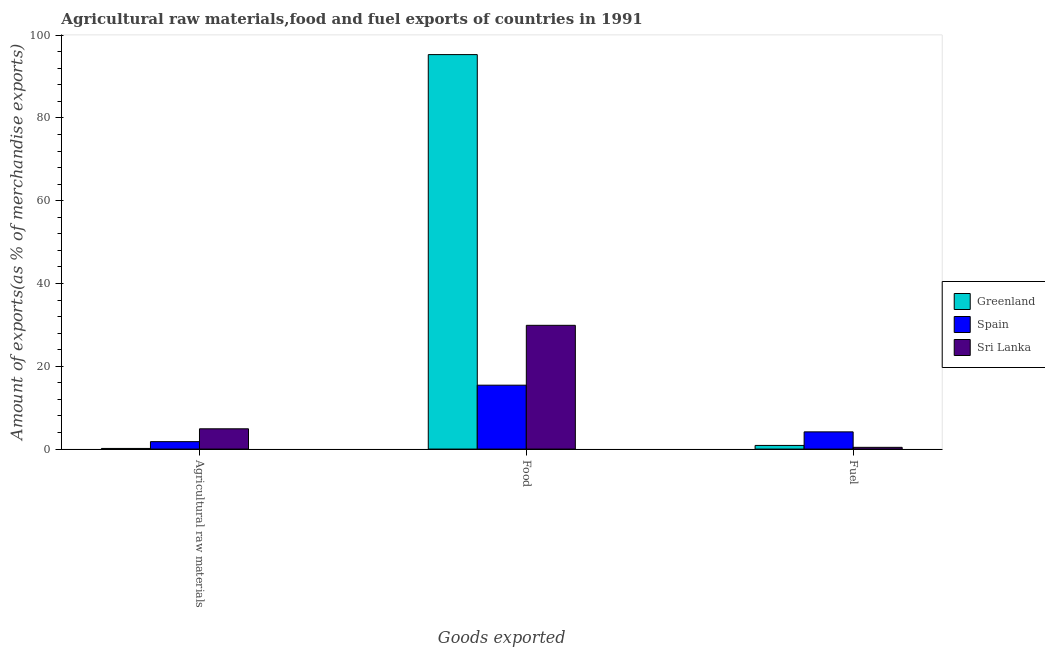How many groups of bars are there?
Your response must be concise. 3. Are the number of bars per tick equal to the number of legend labels?
Provide a succinct answer. Yes. Are the number of bars on each tick of the X-axis equal?
Offer a very short reply. Yes. What is the label of the 2nd group of bars from the left?
Ensure brevity in your answer.  Food. What is the percentage of food exports in Spain?
Your answer should be very brief. 15.44. Across all countries, what is the maximum percentage of raw materials exports?
Your response must be concise. 4.9. Across all countries, what is the minimum percentage of fuel exports?
Provide a short and direct response. 0.42. In which country was the percentage of fuel exports maximum?
Provide a short and direct response. Spain. In which country was the percentage of raw materials exports minimum?
Offer a terse response. Greenland. What is the total percentage of food exports in the graph?
Offer a very short reply. 140.66. What is the difference between the percentage of raw materials exports in Spain and that in Sri Lanka?
Offer a terse response. -3.1. What is the difference between the percentage of fuel exports in Greenland and the percentage of food exports in Sri Lanka?
Offer a very short reply. -29.02. What is the average percentage of food exports per country?
Keep it short and to the point. 46.89. What is the difference between the percentage of raw materials exports and percentage of fuel exports in Spain?
Your answer should be compact. -2.36. What is the ratio of the percentage of food exports in Spain to that in Greenland?
Ensure brevity in your answer.  0.16. Is the percentage of raw materials exports in Greenland less than that in Sri Lanka?
Keep it short and to the point. Yes. Is the difference between the percentage of raw materials exports in Spain and Sri Lanka greater than the difference between the percentage of food exports in Spain and Sri Lanka?
Provide a succinct answer. Yes. What is the difference between the highest and the second highest percentage of food exports?
Keep it short and to the point. 65.41. What is the difference between the highest and the lowest percentage of raw materials exports?
Provide a succinct answer. 4.75. Is the sum of the percentage of fuel exports in Spain and Greenland greater than the maximum percentage of food exports across all countries?
Your response must be concise. No. What does the 1st bar from the left in Agricultural raw materials represents?
Ensure brevity in your answer.  Greenland. What does the 1st bar from the right in Agricultural raw materials represents?
Offer a terse response. Sri Lanka. How many bars are there?
Your answer should be compact. 9. Does the graph contain grids?
Ensure brevity in your answer.  No. Where does the legend appear in the graph?
Keep it short and to the point. Center right. How are the legend labels stacked?
Offer a terse response. Vertical. What is the title of the graph?
Keep it short and to the point. Agricultural raw materials,food and fuel exports of countries in 1991. Does "Iceland" appear as one of the legend labels in the graph?
Your answer should be very brief. No. What is the label or title of the X-axis?
Your response must be concise. Goods exported. What is the label or title of the Y-axis?
Ensure brevity in your answer.  Amount of exports(as % of merchandise exports). What is the Amount of exports(as % of merchandise exports) in Greenland in Agricultural raw materials?
Provide a short and direct response. 0.15. What is the Amount of exports(as % of merchandise exports) of Spain in Agricultural raw materials?
Offer a very short reply. 1.8. What is the Amount of exports(as % of merchandise exports) of Sri Lanka in Agricultural raw materials?
Make the answer very short. 4.9. What is the Amount of exports(as % of merchandise exports) in Greenland in Food?
Your answer should be very brief. 95.32. What is the Amount of exports(as % of merchandise exports) of Spain in Food?
Keep it short and to the point. 15.44. What is the Amount of exports(as % of merchandise exports) in Sri Lanka in Food?
Offer a terse response. 29.9. What is the Amount of exports(as % of merchandise exports) of Greenland in Fuel?
Provide a short and direct response. 0.88. What is the Amount of exports(as % of merchandise exports) in Spain in Fuel?
Your answer should be very brief. 4.16. What is the Amount of exports(as % of merchandise exports) of Sri Lanka in Fuel?
Keep it short and to the point. 0.42. Across all Goods exported, what is the maximum Amount of exports(as % of merchandise exports) in Greenland?
Ensure brevity in your answer.  95.32. Across all Goods exported, what is the maximum Amount of exports(as % of merchandise exports) of Spain?
Your answer should be very brief. 15.44. Across all Goods exported, what is the maximum Amount of exports(as % of merchandise exports) of Sri Lanka?
Your response must be concise. 29.9. Across all Goods exported, what is the minimum Amount of exports(as % of merchandise exports) of Greenland?
Your answer should be compact. 0.15. Across all Goods exported, what is the minimum Amount of exports(as % of merchandise exports) in Spain?
Offer a terse response. 1.8. Across all Goods exported, what is the minimum Amount of exports(as % of merchandise exports) in Sri Lanka?
Provide a short and direct response. 0.42. What is the total Amount of exports(as % of merchandise exports) of Greenland in the graph?
Keep it short and to the point. 96.35. What is the total Amount of exports(as % of merchandise exports) in Spain in the graph?
Give a very brief answer. 21.39. What is the total Amount of exports(as % of merchandise exports) of Sri Lanka in the graph?
Ensure brevity in your answer.  35.22. What is the difference between the Amount of exports(as % of merchandise exports) in Greenland in Agricultural raw materials and that in Food?
Offer a terse response. -95.17. What is the difference between the Amount of exports(as % of merchandise exports) in Spain in Agricultural raw materials and that in Food?
Give a very brief answer. -13.64. What is the difference between the Amount of exports(as % of merchandise exports) in Sri Lanka in Agricultural raw materials and that in Food?
Offer a terse response. -25. What is the difference between the Amount of exports(as % of merchandise exports) in Greenland in Agricultural raw materials and that in Fuel?
Make the answer very short. -0.73. What is the difference between the Amount of exports(as % of merchandise exports) of Spain in Agricultural raw materials and that in Fuel?
Keep it short and to the point. -2.36. What is the difference between the Amount of exports(as % of merchandise exports) in Sri Lanka in Agricultural raw materials and that in Fuel?
Give a very brief answer. 4.48. What is the difference between the Amount of exports(as % of merchandise exports) in Greenland in Food and that in Fuel?
Ensure brevity in your answer.  94.44. What is the difference between the Amount of exports(as % of merchandise exports) in Spain in Food and that in Fuel?
Offer a very short reply. 11.28. What is the difference between the Amount of exports(as % of merchandise exports) of Sri Lanka in Food and that in Fuel?
Your response must be concise. 29.48. What is the difference between the Amount of exports(as % of merchandise exports) of Greenland in Agricultural raw materials and the Amount of exports(as % of merchandise exports) of Spain in Food?
Provide a short and direct response. -15.29. What is the difference between the Amount of exports(as % of merchandise exports) in Greenland in Agricultural raw materials and the Amount of exports(as % of merchandise exports) in Sri Lanka in Food?
Give a very brief answer. -29.75. What is the difference between the Amount of exports(as % of merchandise exports) in Spain in Agricultural raw materials and the Amount of exports(as % of merchandise exports) in Sri Lanka in Food?
Offer a very short reply. -28.11. What is the difference between the Amount of exports(as % of merchandise exports) of Greenland in Agricultural raw materials and the Amount of exports(as % of merchandise exports) of Spain in Fuel?
Give a very brief answer. -4.01. What is the difference between the Amount of exports(as % of merchandise exports) in Greenland in Agricultural raw materials and the Amount of exports(as % of merchandise exports) in Sri Lanka in Fuel?
Offer a very short reply. -0.27. What is the difference between the Amount of exports(as % of merchandise exports) in Spain in Agricultural raw materials and the Amount of exports(as % of merchandise exports) in Sri Lanka in Fuel?
Provide a short and direct response. 1.38. What is the difference between the Amount of exports(as % of merchandise exports) of Greenland in Food and the Amount of exports(as % of merchandise exports) of Spain in Fuel?
Your answer should be compact. 91.16. What is the difference between the Amount of exports(as % of merchandise exports) of Greenland in Food and the Amount of exports(as % of merchandise exports) of Sri Lanka in Fuel?
Your response must be concise. 94.9. What is the difference between the Amount of exports(as % of merchandise exports) in Spain in Food and the Amount of exports(as % of merchandise exports) in Sri Lanka in Fuel?
Your answer should be very brief. 15.02. What is the average Amount of exports(as % of merchandise exports) of Greenland per Goods exported?
Offer a very short reply. 32.12. What is the average Amount of exports(as % of merchandise exports) of Spain per Goods exported?
Your answer should be very brief. 7.13. What is the average Amount of exports(as % of merchandise exports) in Sri Lanka per Goods exported?
Make the answer very short. 11.74. What is the difference between the Amount of exports(as % of merchandise exports) of Greenland and Amount of exports(as % of merchandise exports) of Spain in Agricultural raw materials?
Offer a very short reply. -1.65. What is the difference between the Amount of exports(as % of merchandise exports) of Greenland and Amount of exports(as % of merchandise exports) of Sri Lanka in Agricultural raw materials?
Ensure brevity in your answer.  -4.75. What is the difference between the Amount of exports(as % of merchandise exports) of Spain and Amount of exports(as % of merchandise exports) of Sri Lanka in Agricultural raw materials?
Ensure brevity in your answer.  -3.1. What is the difference between the Amount of exports(as % of merchandise exports) in Greenland and Amount of exports(as % of merchandise exports) in Spain in Food?
Offer a terse response. 79.88. What is the difference between the Amount of exports(as % of merchandise exports) in Greenland and Amount of exports(as % of merchandise exports) in Sri Lanka in Food?
Your answer should be compact. 65.41. What is the difference between the Amount of exports(as % of merchandise exports) of Spain and Amount of exports(as % of merchandise exports) of Sri Lanka in Food?
Offer a very short reply. -14.47. What is the difference between the Amount of exports(as % of merchandise exports) of Greenland and Amount of exports(as % of merchandise exports) of Spain in Fuel?
Provide a succinct answer. -3.28. What is the difference between the Amount of exports(as % of merchandise exports) of Greenland and Amount of exports(as % of merchandise exports) of Sri Lanka in Fuel?
Your answer should be compact. 0.46. What is the difference between the Amount of exports(as % of merchandise exports) in Spain and Amount of exports(as % of merchandise exports) in Sri Lanka in Fuel?
Offer a very short reply. 3.74. What is the ratio of the Amount of exports(as % of merchandise exports) in Greenland in Agricultural raw materials to that in Food?
Keep it short and to the point. 0. What is the ratio of the Amount of exports(as % of merchandise exports) of Spain in Agricultural raw materials to that in Food?
Make the answer very short. 0.12. What is the ratio of the Amount of exports(as % of merchandise exports) in Sri Lanka in Agricultural raw materials to that in Food?
Give a very brief answer. 0.16. What is the ratio of the Amount of exports(as % of merchandise exports) of Greenland in Agricultural raw materials to that in Fuel?
Keep it short and to the point. 0.17. What is the ratio of the Amount of exports(as % of merchandise exports) of Spain in Agricultural raw materials to that in Fuel?
Your answer should be compact. 0.43. What is the ratio of the Amount of exports(as % of merchandise exports) of Sri Lanka in Agricultural raw materials to that in Fuel?
Make the answer very short. 11.64. What is the ratio of the Amount of exports(as % of merchandise exports) of Greenland in Food to that in Fuel?
Offer a very short reply. 108.33. What is the ratio of the Amount of exports(as % of merchandise exports) of Spain in Food to that in Fuel?
Give a very brief answer. 3.71. What is the ratio of the Amount of exports(as % of merchandise exports) of Sri Lanka in Food to that in Fuel?
Your answer should be very brief. 71.04. What is the difference between the highest and the second highest Amount of exports(as % of merchandise exports) of Greenland?
Give a very brief answer. 94.44. What is the difference between the highest and the second highest Amount of exports(as % of merchandise exports) of Spain?
Your answer should be very brief. 11.28. What is the difference between the highest and the second highest Amount of exports(as % of merchandise exports) of Sri Lanka?
Provide a succinct answer. 25. What is the difference between the highest and the lowest Amount of exports(as % of merchandise exports) of Greenland?
Your answer should be compact. 95.17. What is the difference between the highest and the lowest Amount of exports(as % of merchandise exports) in Spain?
Ensure brevity in your answer.  13.64. What is the difference between the highest and the lowest Amount of exports(as % of merchandise exports) in Sri Lanka?
Provide a short and direct response. 29.48. 